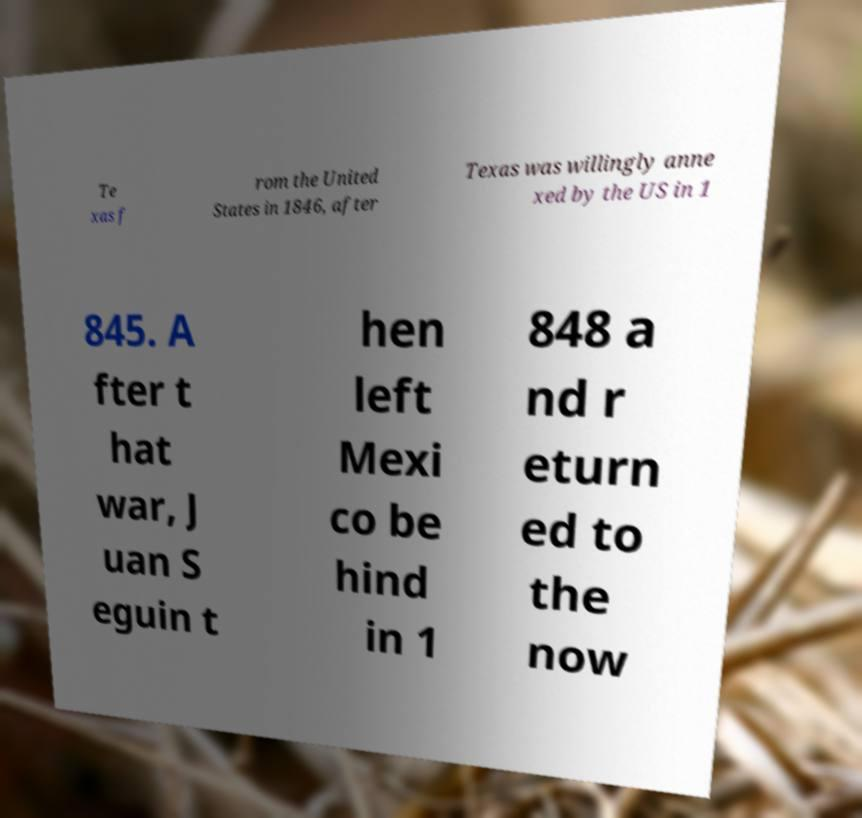I need the written content from this picture converted into text. Can you do that? Te xas f rom the United States in 1846, after Texas was willingly anne xed by the US in 1 845. A fter t hat war, J uan S eguin t hen left Mexi co be hind in 1 848 a nd r eturn ed to the now 